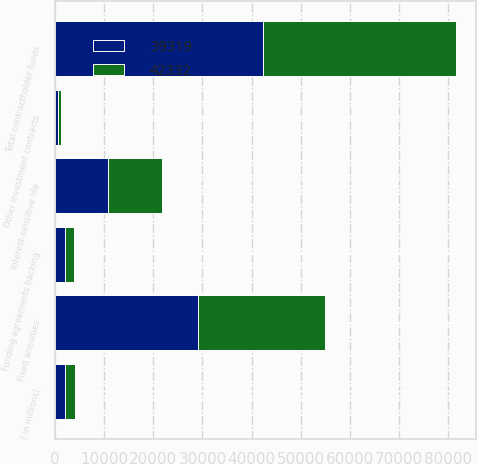Convert chart to OTSL. <chart><loc_0><loc_0><loc_500><loc_500><stacked_bar_chart><ecel><fcel>( in millions)<fcel>Interest-sensitive life<fcel>Fixed annuities<fcel>Funding agreements backing<fcel>Other investment contracts<fcel>Total contractholder funds<nl><fcel>42332<fcel>2012<fcel>11011<fcel>25881<fcel>1867<fcel>560<fcel>39319<nl><fcel>39319<fcel>2011<fcel>10826<fcel>29049<fcel>1929<fcel>528<fcel>42332<nl></chart> 